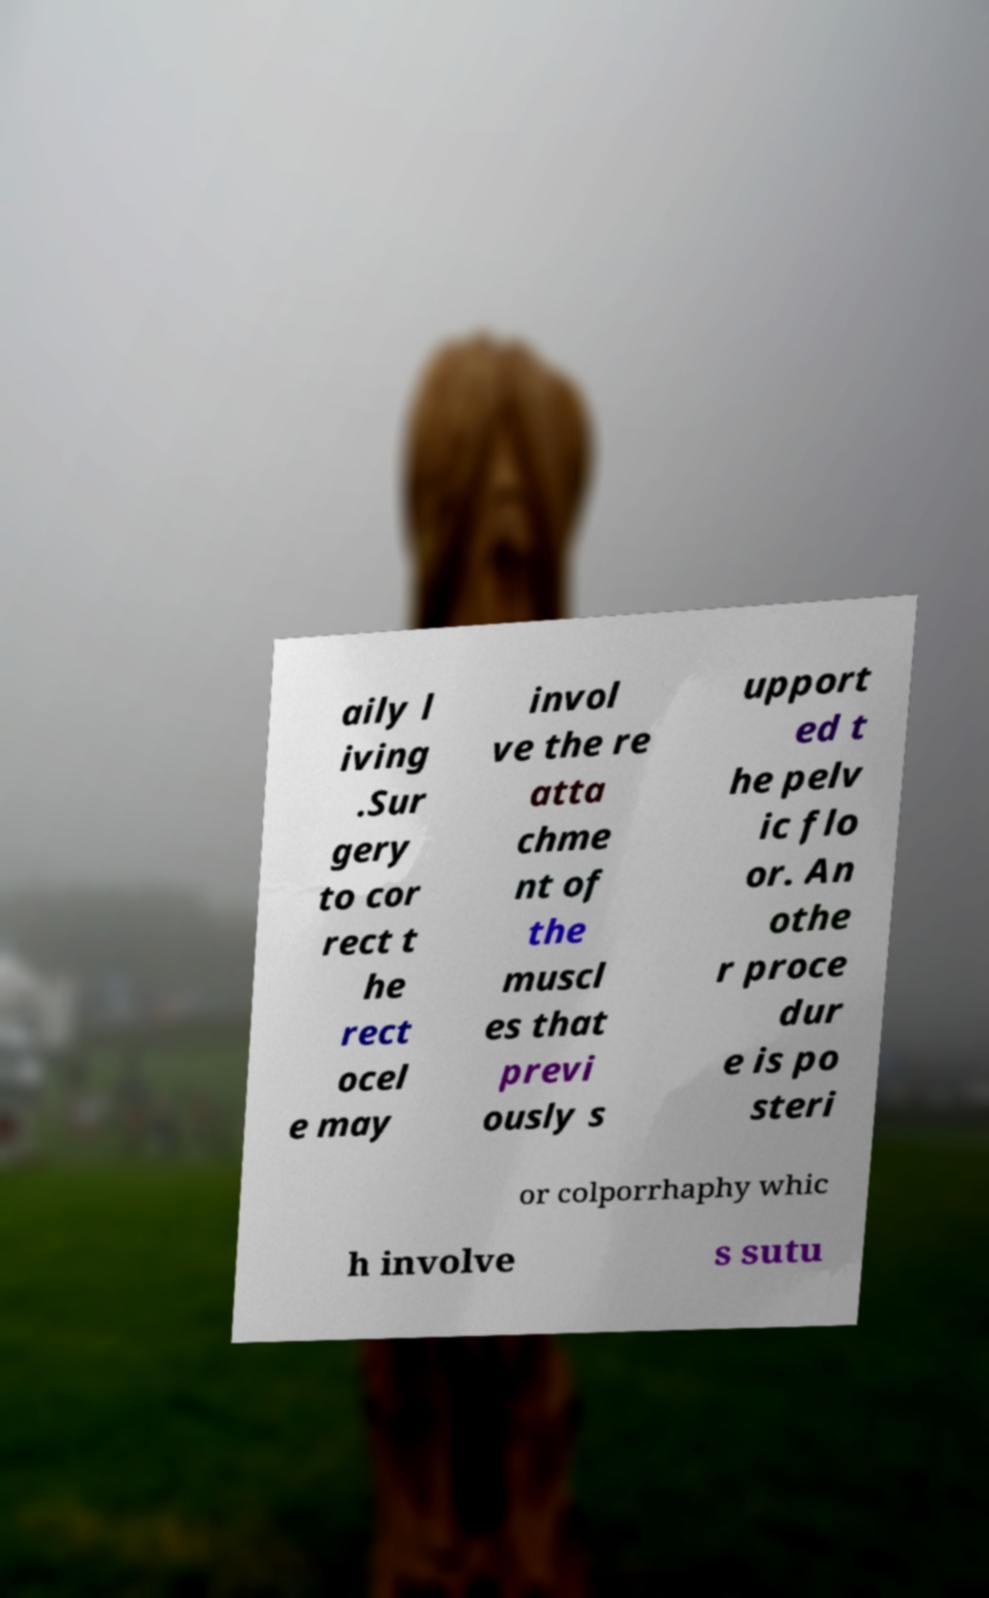I need the written content from this picture converted into text. Can you do that? aily l iving .Sur gery to cor rect t he rect ocel e may invol ve the re atta chme nt of the muscl es that previ ously s upport ed t he pelv ic flo or. An othe r proce dur e is po steri or colporrhaphy whic h involve s sutu 